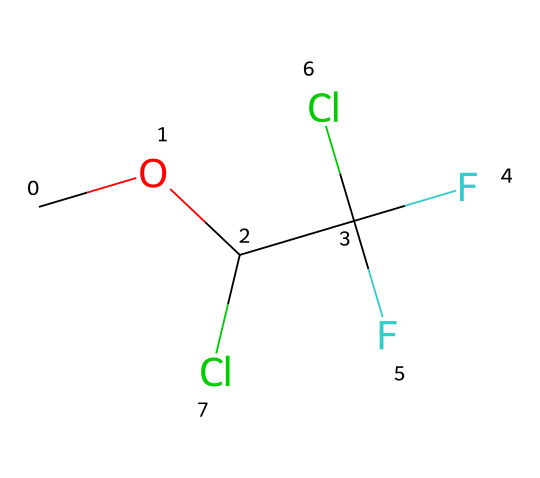What is the molecular formula of methoxyflurane? The SMILES representation indicates the elements present in methoxyflurane: Carbon (C), Oxygen (O), Fluorine (F), and Chlorine (Cl). By counting the individual atoms represented, the molecular formula can be derived as C3H3Cl2F3O.
Answer: C3H3Cl2F3O How many carbon atoms are in the structure? By reviewing the SMILES notation, I can identify three carbon atoms represented by the symbol "C".
Answer: 3 What type of chemical is methoxyflurane? Methoxyflurane is classified as an ether due to the presence of an ether functional group (-O-), where an oxygen atom connects two carbon groups. This feature defines its classification.
Answer: ether What specific element contributes to the anesthetic property of methoxyflurane? The presence of fluorine atoms, as well as the overall structure that allows for inhalational administration, directly relates to its anesthetic properties. The fluorine enhances the volatility and stability of the compound in the gaseous state.
Answer: fluorine What is the total number of chlorine atoms in methoxyflurane? Examining the SMILES representation reveals that there are two chlorine atoms indicated by "Cl".
Answer: 2 How many total hydrogen atoms are present in the molecular structure? In the molecular formula derived earlier, we can see there are three hydrogen atoms represented in methoxyflurane, counted from the components connected to carbon.
Answer: 3 What functional groups are present in methoxyflurane? In the chemical structure of methoxyflurane, there is an ether functional group (-O-) and halogen substituents (the chlorine and fluorine atoms). Both of these groups are essential in determining the properties of the compound.
Answer: ether and halogen 